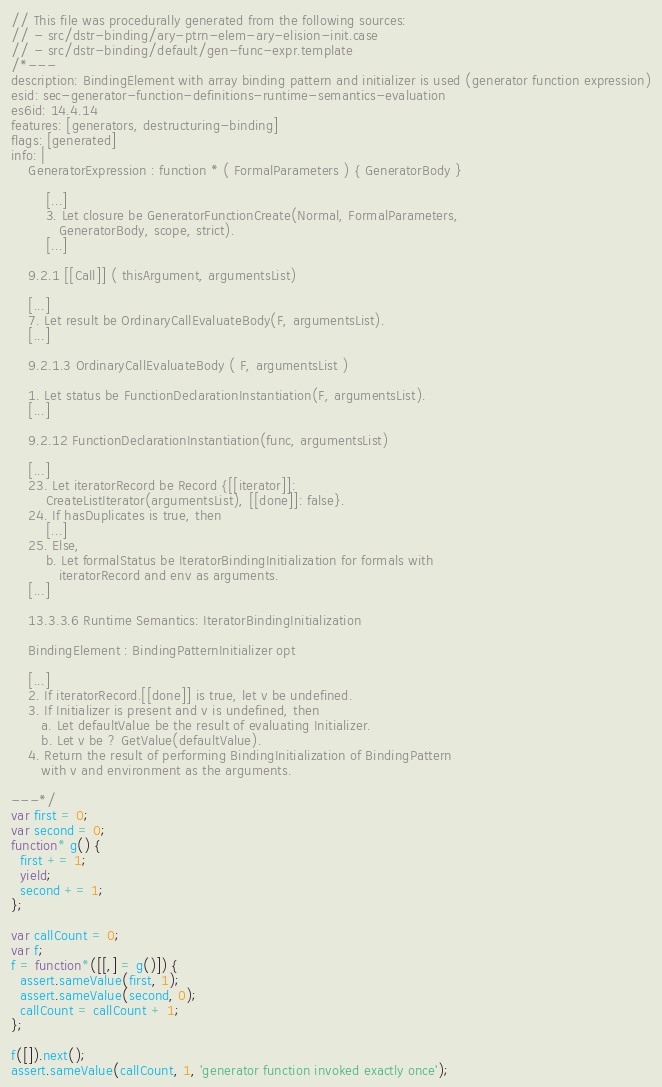Convert code to text. <code><loc_0><loc_0><loc_500><loc_500><_JavaScript_>// This file was procedurally generated from the following sources:
// - src/dstr-binding/ary-ptrn-elem-ary-elision-init.case
// - src/dstr-binding/default/gen-func-expr.template
/*---
description: BindingElement with array binding pattern and initializer is used (generator function expression)
esid: sec-generator-function-definitions-runtime-semantics-evaluation
es6id: 14.4.14
features: [generators, destructuring-binding]
flags: [generated]
info: |
    GeneratorExpression : function * ( FormalParameters ) { GeneratorBody }

        [...]
        3. Let closure be GeneratorFunctionCreate(Normal, FormalParameters,
           GeneratorBody, scope, strict).
        [...]

    9.2.1 [[Call]] ( thisArgument, argumentsList)

    [...]
    7. Let result be OrdinaryCallEvaluateBody(F, argumentsList).
    [...]

    9.2.1.3 OrdinaryCallEvaluateBody ( F, argumentsList )

    1. Let status be FunctionDeclarationInstantiation(F, argumentsList).
    [...]

    9.2.12 FunctionDeclarationInstantiation(func, argumentsList)

    [...]
    23. Let iteratorRecord be Record {[[iterator]]:
        CreateListIterator(argumentsList), [[done]]: false}.
    24. If hasDuplicates is true, then
        [...]
    25. Else,
        b. Let formalStatus be IteratorBindingInitialization for formals with
           iteratorRecord and env as arguments.
    [...]

    13.3.3.6 Runtime Semantics: IteratorBindingInitialization

    BindingElement : BindingPatternInitializer opt

    [...]
    2. If iteratorRecord.[[done]] is true, let v be undefined.
    3. If Initializer is present and v is undefined, then
       a. Let defaultValue be the result of evaluating Initializer.
       b. Let v be ? GetValue(defaultValue).
    4. Return the result of performing BindingInitialization of BindingPattern
       with v and environment as the arguments.

---*/
var first = 0;
var second = 0;
function* g() {
  first += 1;
  yield;
  second += 1;
};

var callCount = 0;
var f;
f = function*([[,] = g()]) {
  assert.sameValue(first, 1);
  assert.sameValue(second, 0);
  callCount = callCount + 1;
};

f([]).next();
assert.sameValue(callCount, 1, 'generator function invoked exactly once');
</code> 